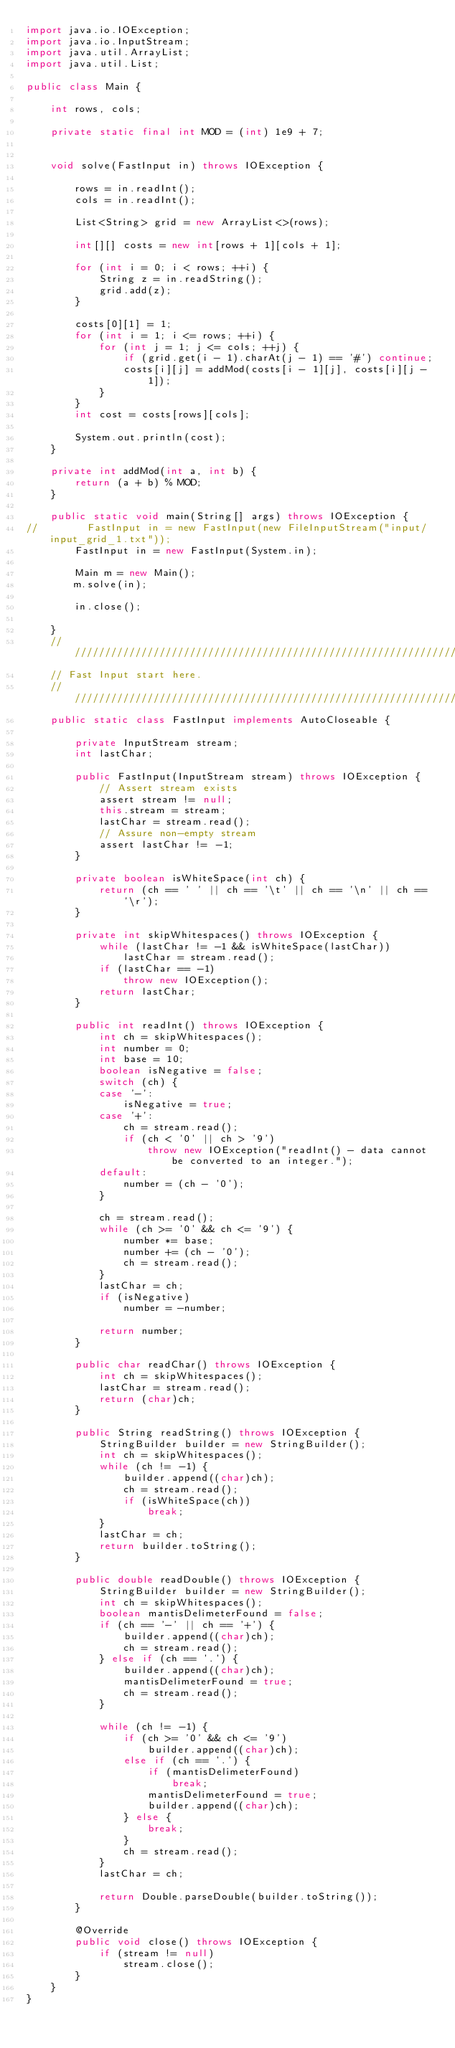Convert code to text. <code><loc_0><loc_0><loc_500><loc_500><_Java_>import java.io.IOException;
import java.io.InputStream;
import java.util.ArrayList;
import java.util.List;

public class Main {
    
    int rows, cols;
    
    private static final int MOD = (int) 1e9 + 7; 
    
    
    void solve(FastInput in) throws IOException {
        
        rows = in.readInt();
        cols = in.readInt();

        List<String> grid = new ArrayList<>(rows);
        
        int[][] costs = new int[rows + 1][cols + 1];

        for (int i = 0; i < rows; ++i) {
            String z = in.readString();
            grid.add(z);
        }
        
        costs[0][1] = 1;
        for (int i = 1; i <= rows; ++i) {
            for (int j = 1; j <= cols; ++j) {
                if (grid.get(i - 1).charAt(j - 1) == '#') continue;
                costs[i][j] = addMod(costs[i - 1][j], costs[i][j - 1]);
            }
        }
        int cost = costs[rows][cols];
        
        System.out.println(cost);
    }
    
    private int addMod(int a, int b) {
        return (a + b) % MOD;
    }

    public static void main(String[] args) throws IOException {
//        FastInput in = new FastInput(new FileInputStream("input/input_grid_1.txt"));
        FastInput in = new FastInput(System.in);
        
        Main m = new Main();
        m.solve(in);
        
        in.close();
        
    }
    ///////////////////////////////////////////////////////////////////////////
    // Fast Input start here.
    ///////////////////////////////////////////////////////////////////////////
    public static class FastInput implements AutoCloseable {

        private InputStream stream;
        int lastChar;

        public FastInput(InputStream stream) throws IOException {
            // Assert stream exists
            assert stream != null;
            this.stream = stream;
            lastChar = stream.read();
            // Assure non-empty stream
            assert lastChar != -1;
        }

        private boolean isWhiteSpace(int ch) {
            return (ch == ' ' || ch == '\t' || ch == '\n' || ch == '\r');
        }

        private int skipWhitespaces() throws IOException {
            while (lastChar != -1 && isWhiteSpace(lastChar))
                lastChar = stream.read();
            if (lastChar == -1)
                throw new IOException();
            return lastChar;
        }

        public int readInt() throws IOException {
            int ch = skipWhitespaces();
            int number = 0;
            int base = 10;
            boolean isNegative = false;
            switch (ch) {
            case '-':
                isNegative = true;
            case '+':
                ch = stream.read();
                if (ch < '0' || ch > '9')
                    throw new IOException("readInt() - data cannot be converted to an integer.");
            default:
                number = (ch - '0');
            }

            ch = stream.read();
            while (ch >= '0' && ch <= '9') {
                number *= base;
                number += (ch - '0');
                ch = stream.read();
            }
            lastChar = ch;
            if (isNegative)
                number = -number;

            return number;
        }

        public char readChar() throws IOException {
            int ch = skipWhitespaces();
            lastChar = stream.read();
            return (char)ch;
        }

        public String readString() throws IOException {
            StringBuilder builder = new StringBuilder();
            int ch = skipWhitespaces();
            while (ch != -1) {
                builder.append((char)ch);
                ch = stream.read();
                if (isWhiteSpace(ch))
                    break;
            }
            lastChar = ch;
            return builder.toString();
        }

        public double readDouble() throws IOException {
            StringBuilder builder = new StringBuilder();
            int ch = skipWhitespaces();
            boolean mantisDelimeterFound = false;
            if (ch == '-' || ch == '+') {
                builder.append((char)ch);
                ch = stream.read();
            } else if (ch == '.') {
                builder.append((char)ch);
                mantisDelimeterFound = true;
                ch = stream.read();
            }

            while (ch != -1) {
                if (ch >= '0' && ch <= '9')
                    builder.append((char)ch);
                else if (ch == '.') {
                    if (mantisDelimeterFound)
                        break;
                    mantisDelimeterFound = true;
                    builder.append((char)ch);
                } else {
                    break;
                }
                ch = stream.read();
            }
            lastChar = ch;

            return Double.parseDouble(builder.toString());
        }

        @Override
        public void close() throws IOException {
            if (stream != null)
                stream.close();
        }
    }    
}</code> 